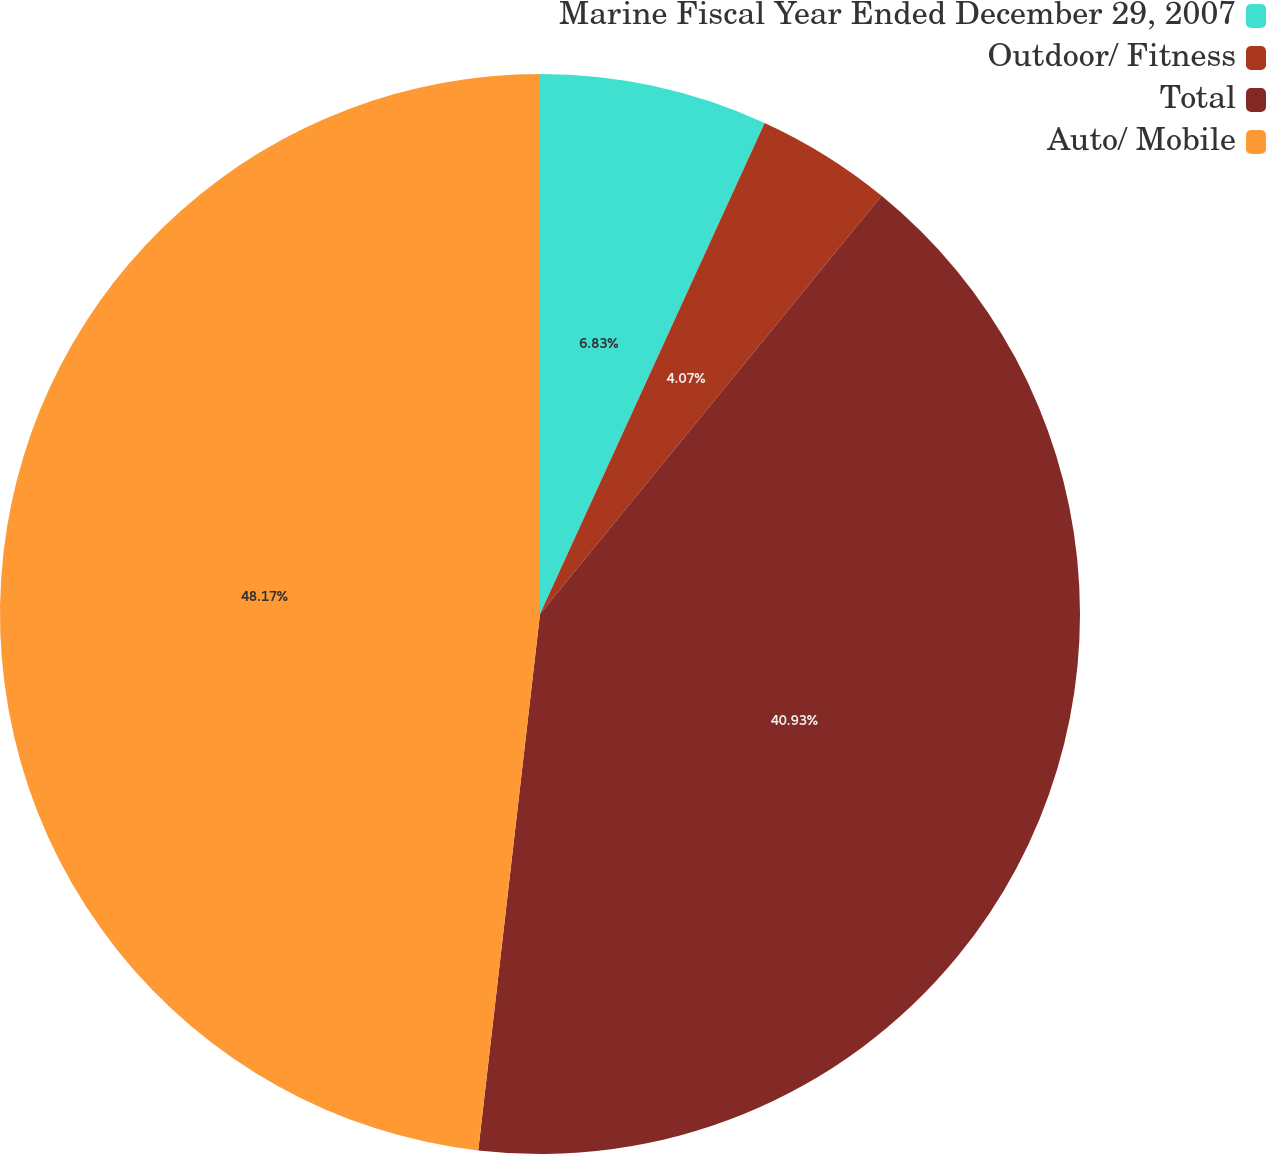Convert chart. <chart><loc_0><loc_0><loc_500><loc_500><pie_chart><fcel>Marine Fiscal Year Ended December 29, 2007<fcel>Outdoor/ Fitness<fcel>Total<fcel>Auto/ Mobile<nl><fcel>6.83%<fcel>4.07%<fcel>40.93%<fcel>48.18%<nl></chart> 